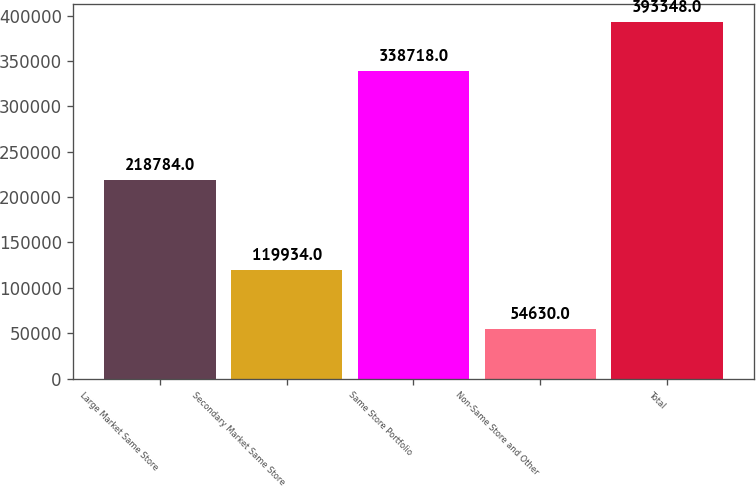Convert chart. <chart><loc_0><loc_0><loc_500><loc_500><bar_chart><fcel>Large Market Same Store<fcel>Secondary Market Same Store<fcel>Same Store Portfolio<fcel>Non-Same Store and Other<fcel>Total<nl><fcel>218784<fcel>119934<fcel>338718<fcel>54630<fcel>393348<nl></chart> 